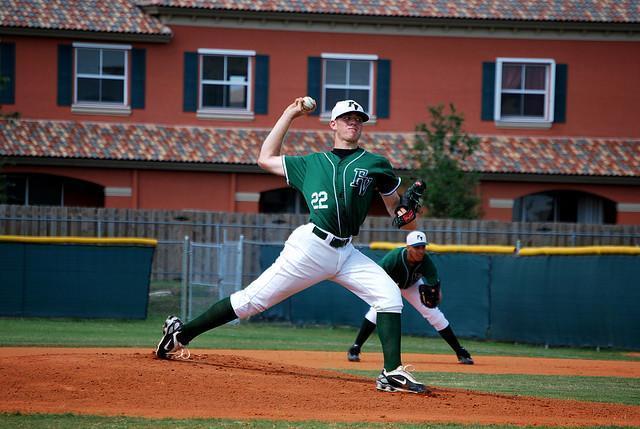How many people are visible?
Give a very brief answer. 2. 